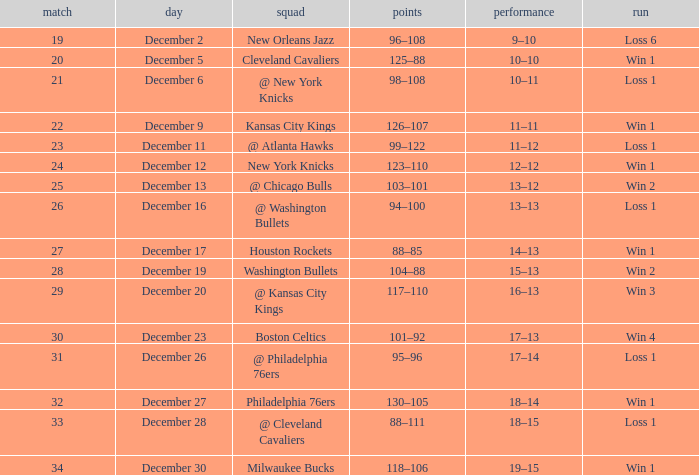What is the Score of the Game with a Record of 13–12? 103–101. 